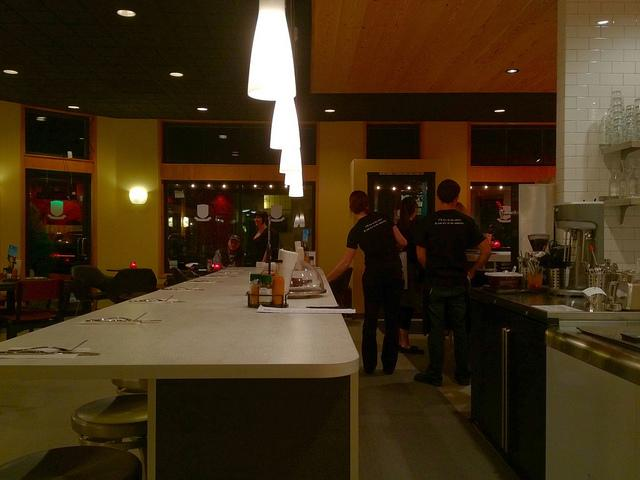What type of counter is shown? restaurant 